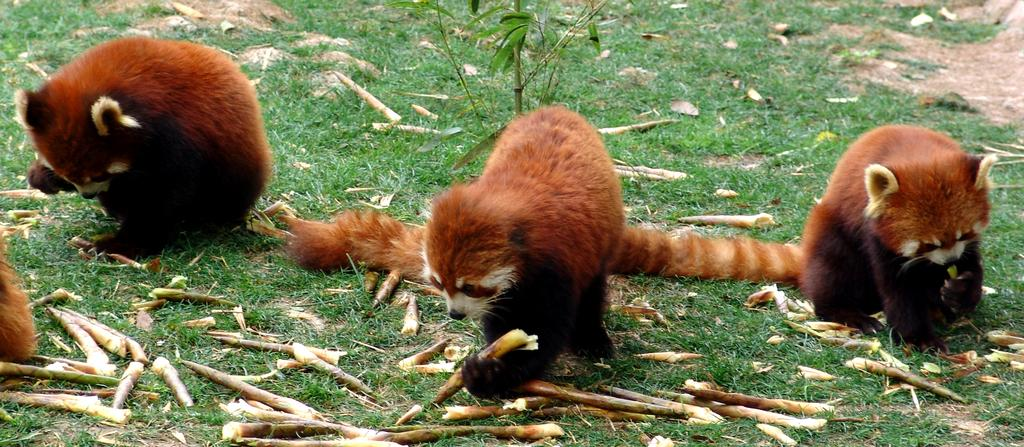What type of living organisms can be seen on the ground in the image? There are animals on the ground in the image. What type of vegetation is present in the image? There is a plant and grass in the image. What else can be found on the ground in the image? There are objects on the ground in the image. What type of crowd can be seen gathering around the moon in the image? There is no crowd or moon present in the image; it features animals, plants, grass, and objects on the ground. What kind of rock is being used by the animals to climb in the image? There is no rock present in the image; it only shows animals, plants, grass, and objects on the ground. 